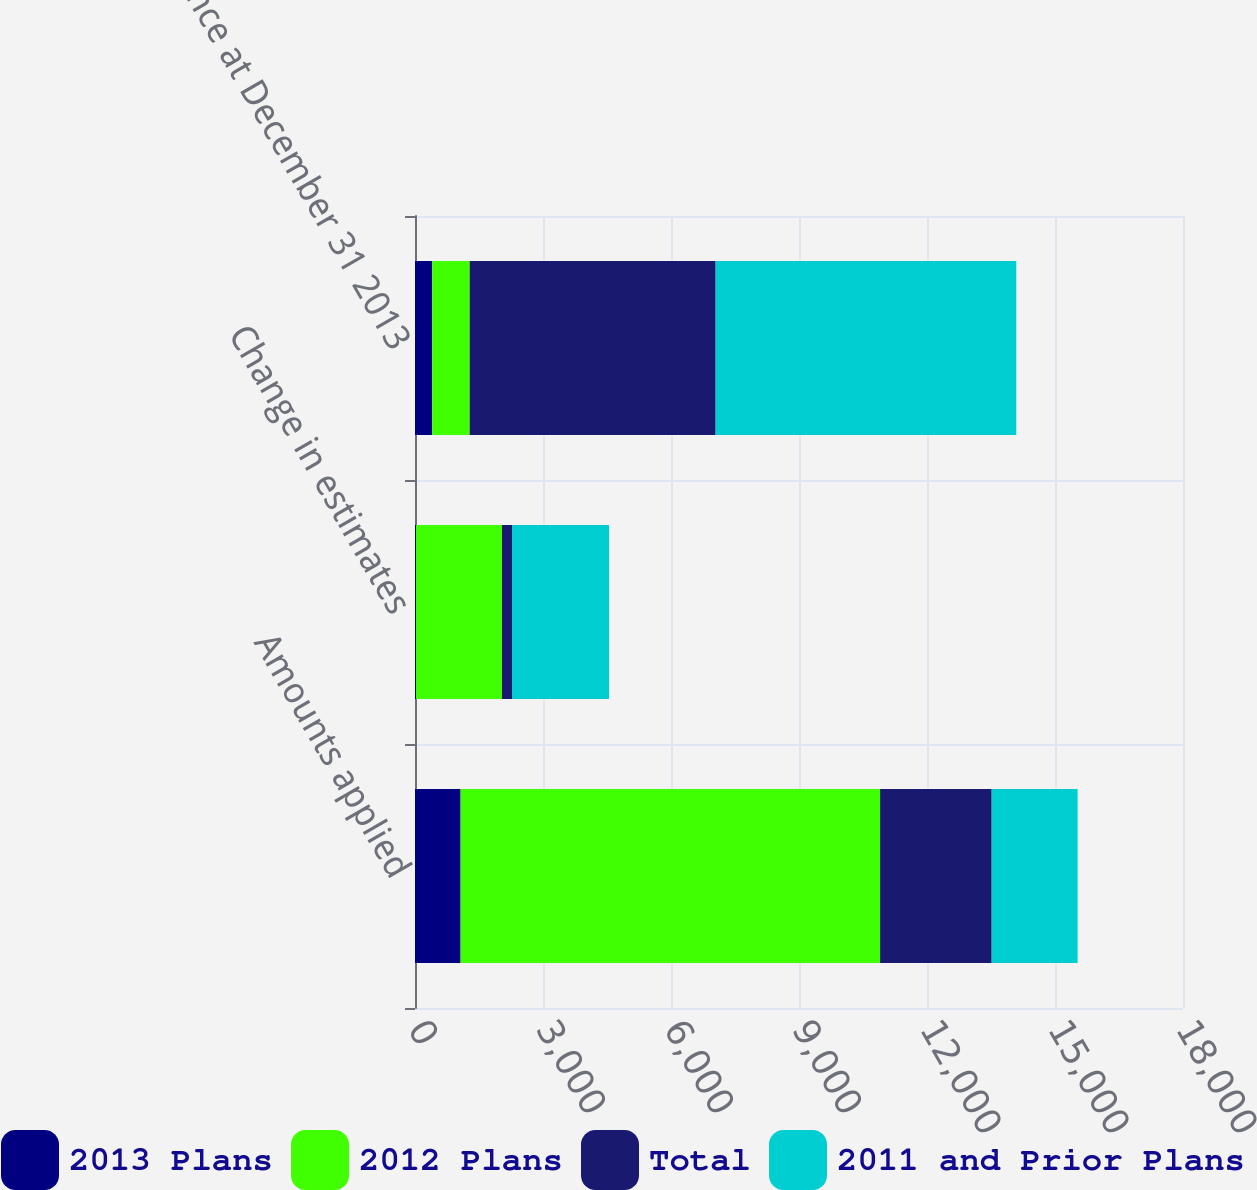<chart> <loc_0><loc_0><loc_500><loc_500><stacked_bar_chart><ecel><fcel>Amounts applied<fcel>Change in estimates<fcel>Balance at December 31 2013<nl><fcel>2013 Plans<fcel>1069<fcel>24<fcel>402<nl><fcel>2012 Plans<fcel>9832<fcel>2014<fcel>880<nl><fcel>Total<fcel>2615<fcel>236<fcel>5764<nl><fcel>2011 and Prior Plans<fcel>2014<fcel>2274<fcel>7046<nl></chart> 